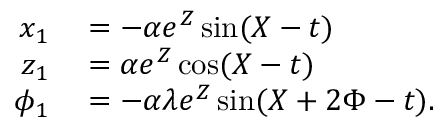<formula> <loc_0><loc_0><loc_500><loc_500>\begin{array} { r l } { x _ { 1 } } & = - \alpha e ^ { Z } \sin ( X - t ) } \\ { z _ { 1 } } & = \alpha e ^ { Z } \cos ( X - t ) } \\ { \phi _ { 1 } } & = - \alpha \lambda e ^ { Z } \sin ( X + 2 \Phi - t ) . } \end{array}</formula> 